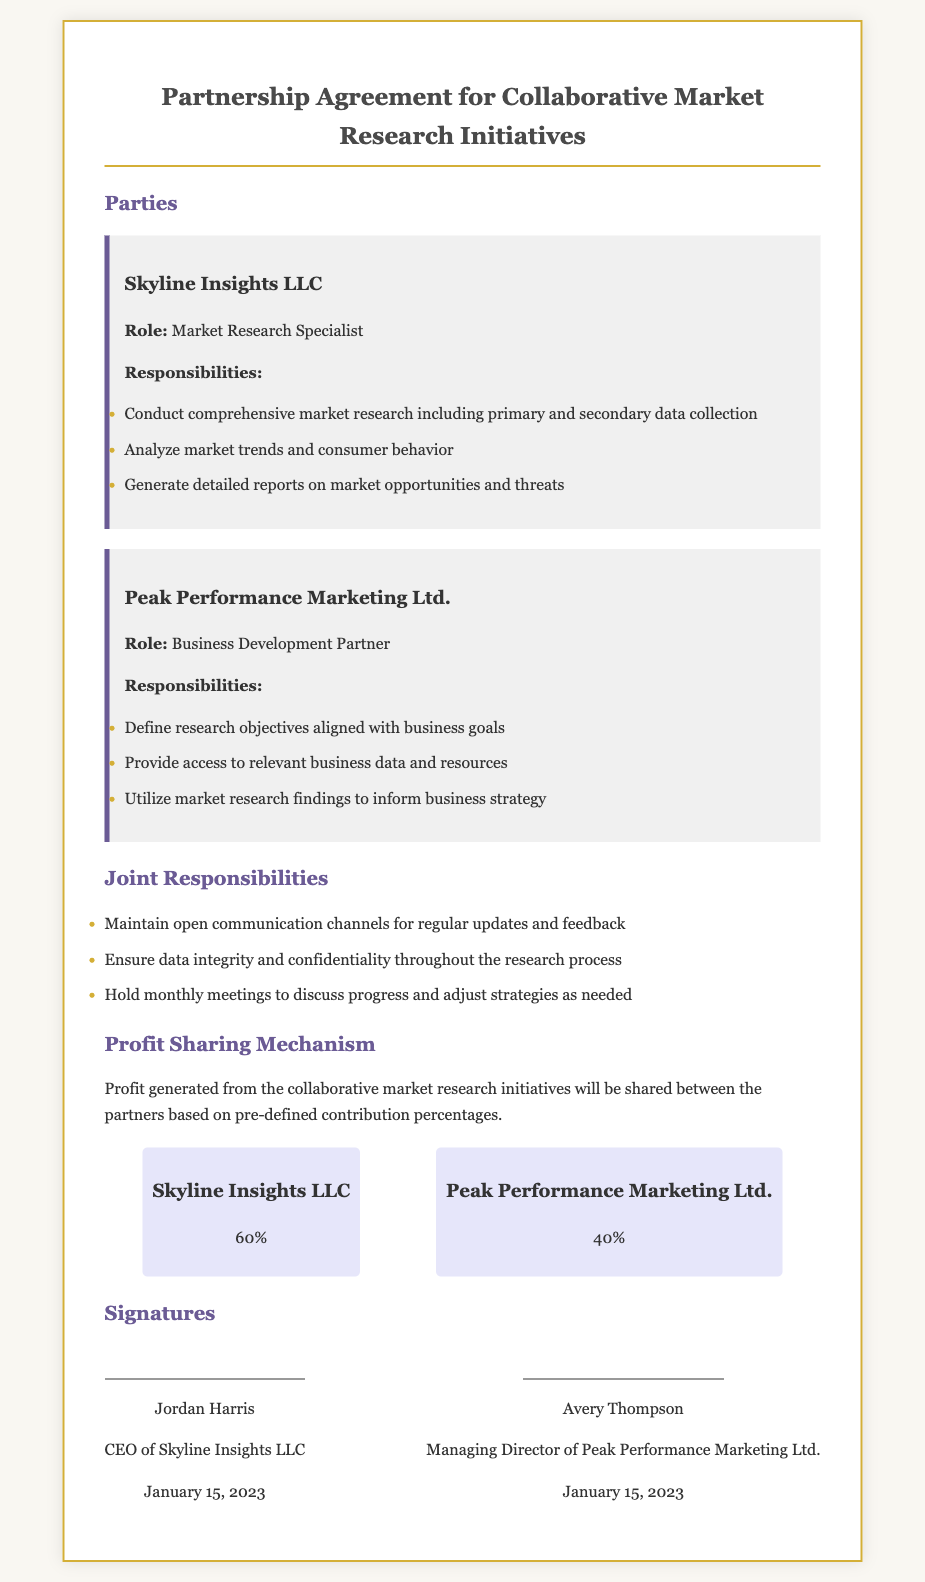What is the title of the document? The title is the main heading of the document indicating its purpose.
Answer: Partnership Agreement for Collaborative Market Research Initiatives Who are the parties involved in the partnership? The parties are specified in the 'Parties' section of the document.
Answer: Skyline Insights LLC and Peak Performance Marketing Ltd What is the profit share percentage for Skyline Insights LLC? The profit-sharing mechanism outlines the distribution percentages for each partner.
Answer: 60% What is the role of Peak Performance Marketing Ltd.? Each party's role is described to clarify their responsibilities in the agreement.
Answer: Business Development Partner How often are meetings scheduled to discuss progress? The frequency of meetings is mentioned under 'Joint Responsibilities'.
Answer: Monthly What date was the agreement signed? The signing date is included under the signatures section at the end of the document.
Answer: January 15, 2023 What is one responsibility of Skyline Insights LLC? Responsibilities for each party are listed, providing role-specific tasks.
Answer: Conduct comprehensive market research including primary and secondary data collection What is the profit share percentage for Peak Performance Marketing Ltd.? The profit-sharing details indicate each party's share in the profits.
Answer: 40% What is one of the joint responsibilities of the parties? Joint responsibilities are shared duties that both partners must fulfill together.
Answer: Maintain open communication channels for regular updates and feedback 